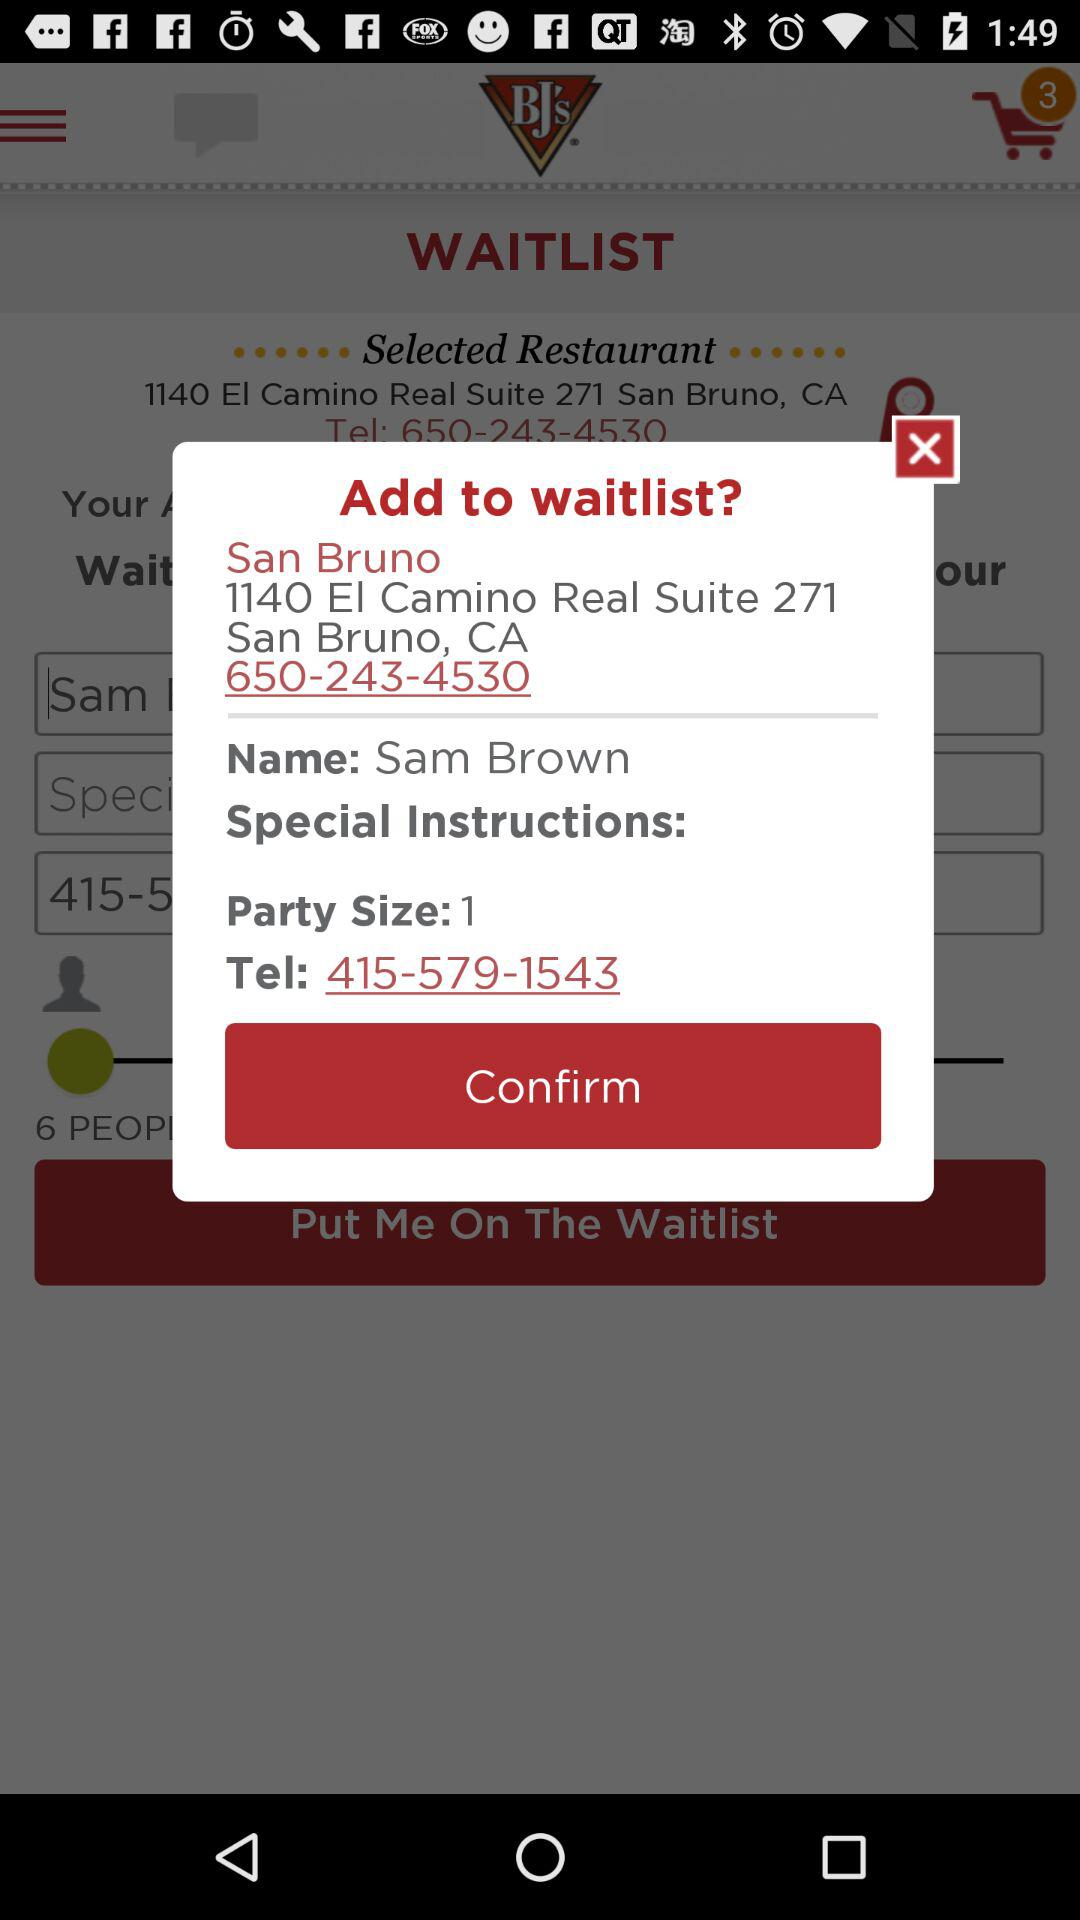What is the address of the user? The address of the user is 1140 El Camino Real Suite 271 San Bruno, CA. 